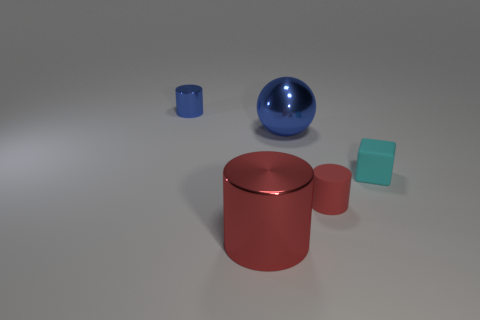There is another cylinder that is the same color as the big metal cylinder; what is it made of?
Make the answer very short. Rubber. Does the big cylinder have the same color as the rubber cylinder?
Your response must be concise. Yes. Are there more blue balls to the left of the block than tiny red objects that are on the left side of the blue sphere?
Give a very brief answer. Yes. There is a cylinder that is in front of the red rubber cylinder; what is its color?
Your response must be concise. Red. Is there another object that has the same shape as the tiny blue thing?
Give a very brief answer. Yes. What number of green things are either large cylinders or tiny blocks?
Give a very brief answer. 0. Are there any red metal objects that have the same size as the sphere?
Your answer should be compact. Yes. What number of cylinders are there?
Offer a very short reply. 3. How many big objects are either red metal cylinders or blue metal things?
Give a very brief answer. 2. What is the color of the object to the right of the small cylinder in front of the cylinder behind the cube?
Give a very brief answer. Cyan. 